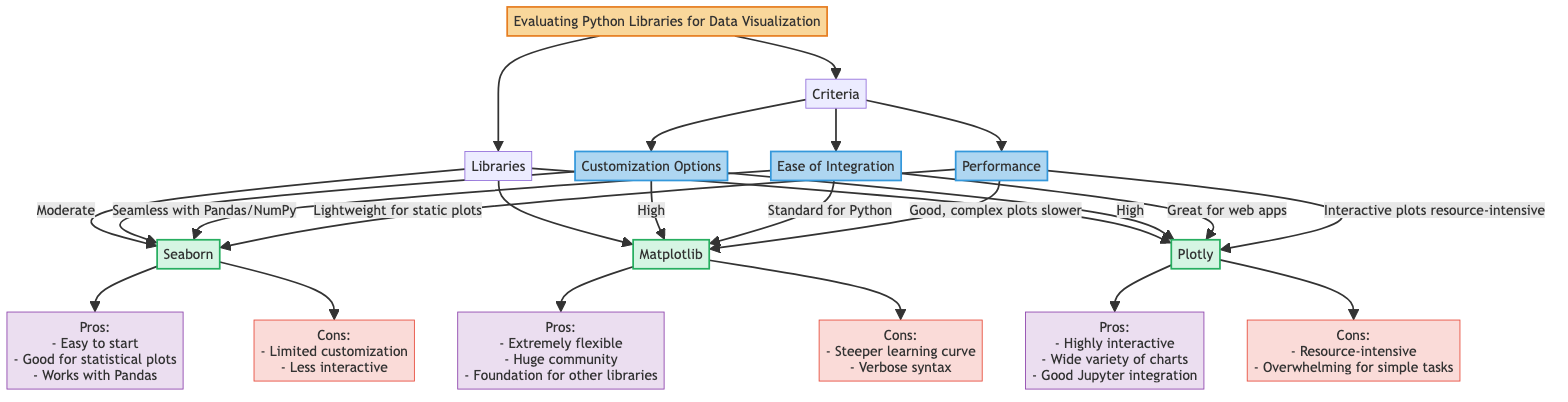What's the customization option level of Seaborn? According to the "Customization Options" section in the diagram, Seaborn is listed as having a "Moderate" level of customization.
Answer: Moderate What is the main advantage of using Matplotlib? Matplotlib has several advantages listed in its pros, including being "Extremely flexible and customizable." This suggests its key strength is its flexibility in customization.
Answer: Extremely flexible and customizable How many libraries are listed in the diagram? The diagram lists three distinct libraries under the "Libraries" section, which are Seaborn, Matplotlib, and Plotly.
Answer: Three Which library integrates seamlessly with Pandas/NumPy? The diagram indicates that Seaborn provides seamless integration with both Pandas and NumPy, making it a go-to choice for users familiar with those libraries.
Answer: Seaborn Which library has a higher performance for complex plots, Matplotlib or Plotly? Based on the "Performance" section, Matplotlib is described as "Good, but complex plots may be slower," while Plotly's interactive plots are stated as "resource-intensive." Comparing both, Matplotlib offers better performance for complex plots.
Answer: Matplotlib Which library is considered less interactive? In the "Cons" section for Seaborn, it states that it is "Less interactive," which clearly identifies it as the library with lower interactivity compared to others like Plotly.
Answer: Seaborn What is a drawback of using Plotly? Plotly has two notable cons listed: it is "resource-intensive for large datasets" and can be "overwhelming for simple tasks." Therefore, both of these factors can be considered drawbacks.
Answer: Resource-intensive for large datasets Which library offers a great variety of chart types? Under the "Pros" for Plotly, it is mentioned that it "Supports a wide variety of chart types," making it stand out for users seeking diverse visualization options.
Answer: Plotly What relationship do customization options have with flexibility for Matplotlib? The diagram shows that Matplotlib is linked directly as having "High" customization options, which correlates with its overall strength in flexibility and customization among the libraries listed.
Answer: High customization options 